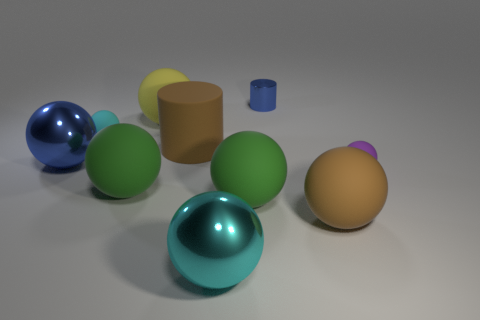The big shiny thing right of the small cyan matte ball has what shape?
Make the answer very short. Sphere. There is a big blue thing; is it the same shape as the green matte object left of the yellow matte ball?
Provide a succinct answer. Yes. Are there the same number of cyan metallic spheres that are behind the small purple sphere and yellow matte objects in front of the tiny metal thing?
Provide a succinct answer. No. There is a rubber thing that is the same color as the large matte cylinder; what shape is it?
Provide a succinct answer. Sphere. There is a small matte thing to the right of the shiny cylinder; is it the same color as the tiny rubber thing left of the small metallic thing?
Your answer should be very brief. No. Is the number of objects in front of the purple object greater than the number of big yellow rubber objects?
Your response must be concise. Yes. What is the material of the big brown cylinder?
Your response must be concise. Rubber. The large thing that is the same material as the large cyan ball is what shape?
Make the answer very short. Sphere. There is a brown matte object that is on the left side of the brown rubber thing that is in front of the big blue thing; what size is it?
Offer a terse response. Large. There is a small ball that is left of the purple rubber sphere; what is its color?
Your response must be concise. Cyan. 